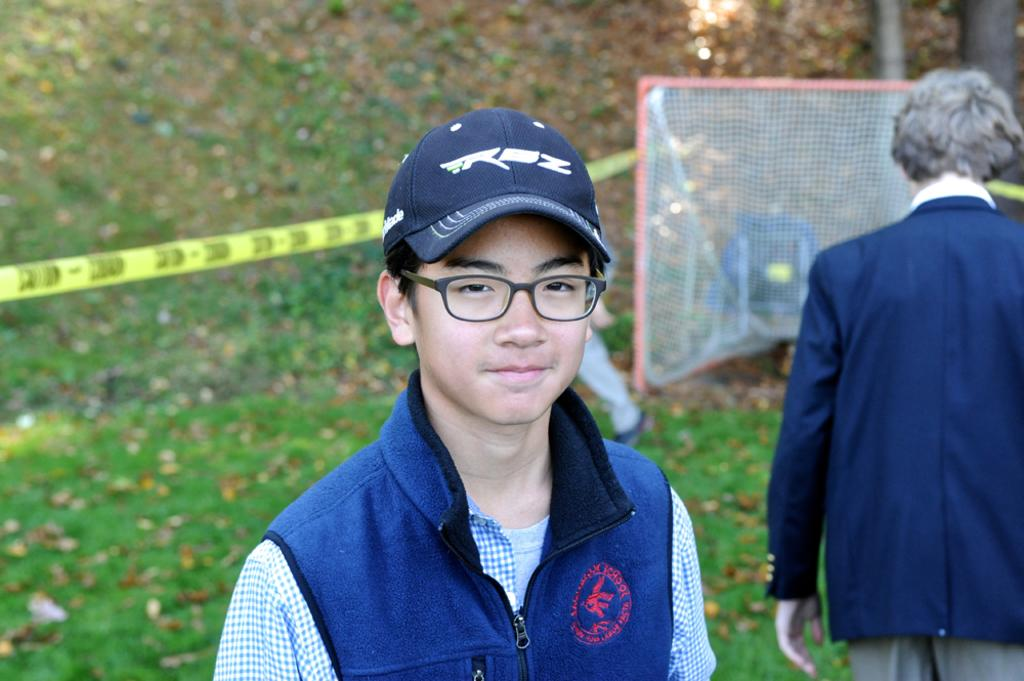How many people are in the image? There are people in the image, but the exact number is not specified. Can you describe the boy in the middle of the image? The boy in the middle of the image is wearing spectacles and a cap. What can be seen in the background of the image? There is grass and a net in the background of the image. What type of twig is the baby holding in the image? There is no baby present in the image, and therefore no twig can be observed. 